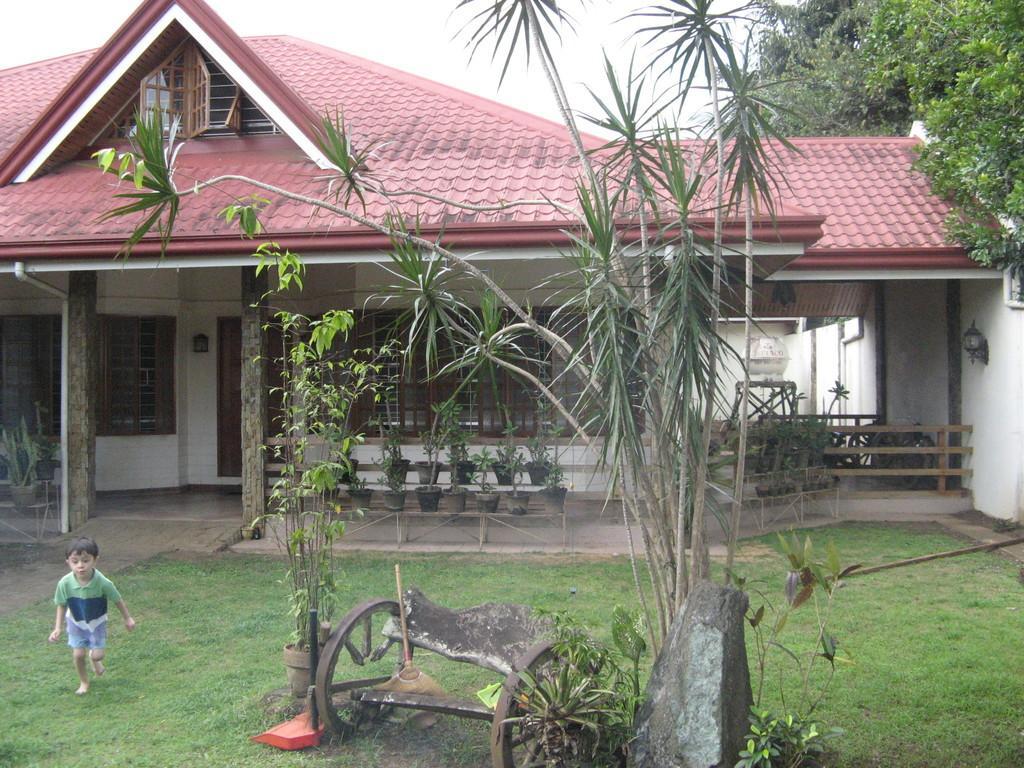Please provide a concise description of this image. In this image there is a grass land, on that grass land a boy is running and there are plants, stone, wheels, in the background there is a house, in that house there are pots, to that house there are windows, doors, in the top right there are trees. 